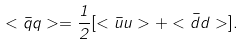<formula> <loc_0><loc_0><loc_500><loc_500>< { \bar { q } } q > = \frac { 1 } { 2 } [ < { \bar { u } } u > + < { \bar { d } } d > ] .</formula> 